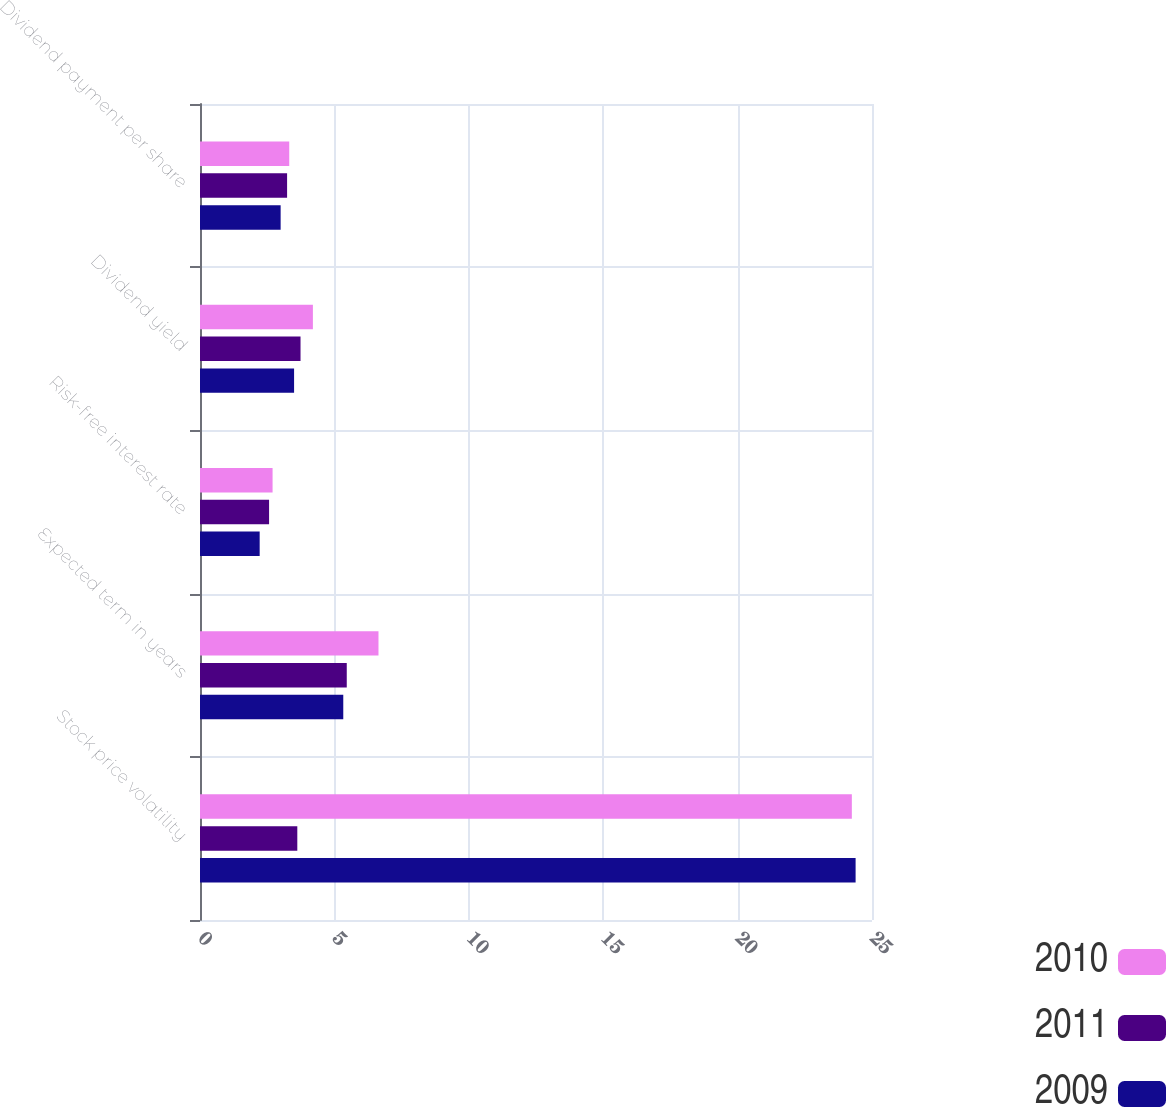Convert chart. <chart><loc_0><loc_0><loc_500><loc_500><stacked_bar_chart><ecel><fcel>Stock price volatility<fcel>Expected term in years<fcel>Risk-free interest rate<fcel>Dividend yield<fcel>Dividend payment per share<nl><fcel>2010<fcel>24.25<fcel>6.64<fcel>2.7<fcel>4.2<fcel>3.32<nl><fcel>2011<fcel>3.62<fcel>5.46<fcel>2.57<fcel>3.74<fcel>3.24<nl><fcel>2009<fcel>24.39<fcel>5.33<fcel>2.22<fcel>3.5<fcel>3<nl></chart> 